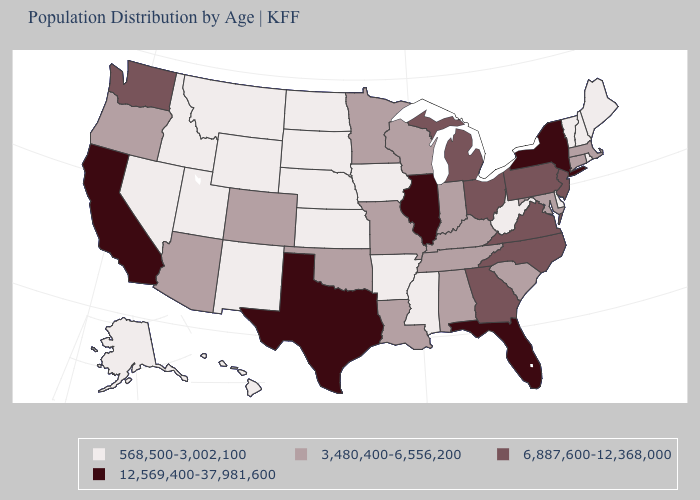Name the states that have a value in the range 568,500-3,002,100?
Keep it brief. Alaska, Arkansas, Delaware, Hawaii, Idaho, Iowa, Kansas, Maine, Mississippi, Montana, Nebraska, Nevada, New Hampshire, New Mexico, North Dakota, Rhode Island, South Dakota, Utah, Vermont, West Virginia, Wyoming. Does Alaska have the lowest value in the West?
Be succinct. Yes. Name the states that have a value in the range 3,480,400-6,556,200?
Quick response, please. Alabama, Arizona, Colorado, Connecticut, Indiana, Kentucky, Louisiana, Maryland, Massachusetts, Minnesota, Missouri, Oklahoma, Oregon, South Carolina, Tennessee, Wisconsin. Does Montana have the lowest value in the USA?
Concise answer only. Yes. Name the states that have a value in the range 6,887,600-12,368,000?
Answer briefly. Georgia, Michigan, New Jersey, North Carolina, Ohio, Pennsylvania, Virginia, Washington. Does Illinois have the highest value in the MidWest?
Be succinct. Yes. Does Wisconsin have the highest value in the USA?
Give a very brief answer. No. Does Pennsylvania have the lowest value in the Northeast?
Be succinct. No. Does West Virginia have a lower value than Oklahoma?
Be succinct. Yes. Which states have the lowest value in the South?
Keep it brief. Arkansas, Delaware, Mississippi, West Virginia. What is the value of New Mexico?
Concise answer only. 568,500-3,002,100. Which states hav the highest value in the South?
Write a very short answer. Florida, Texas. Does West Virginia have a lower value than Indiana?
Keep it brief. Yes. Name the states that have a value in the range 12,569,400-37,981,600?
Write a very short answer. California, Florida, Illinois, New York, Texas. 